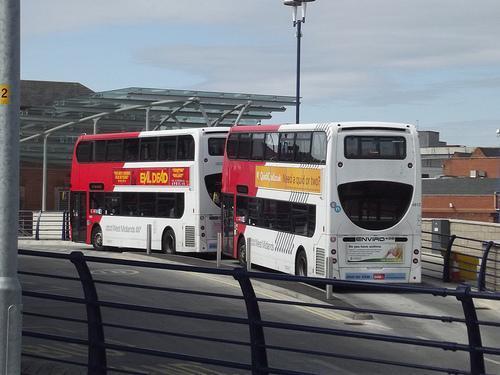How many vehicles are there?
Give a very brief answer. 2. How many buses have a yellow advertisement?
Give a very brief answer. 1. 